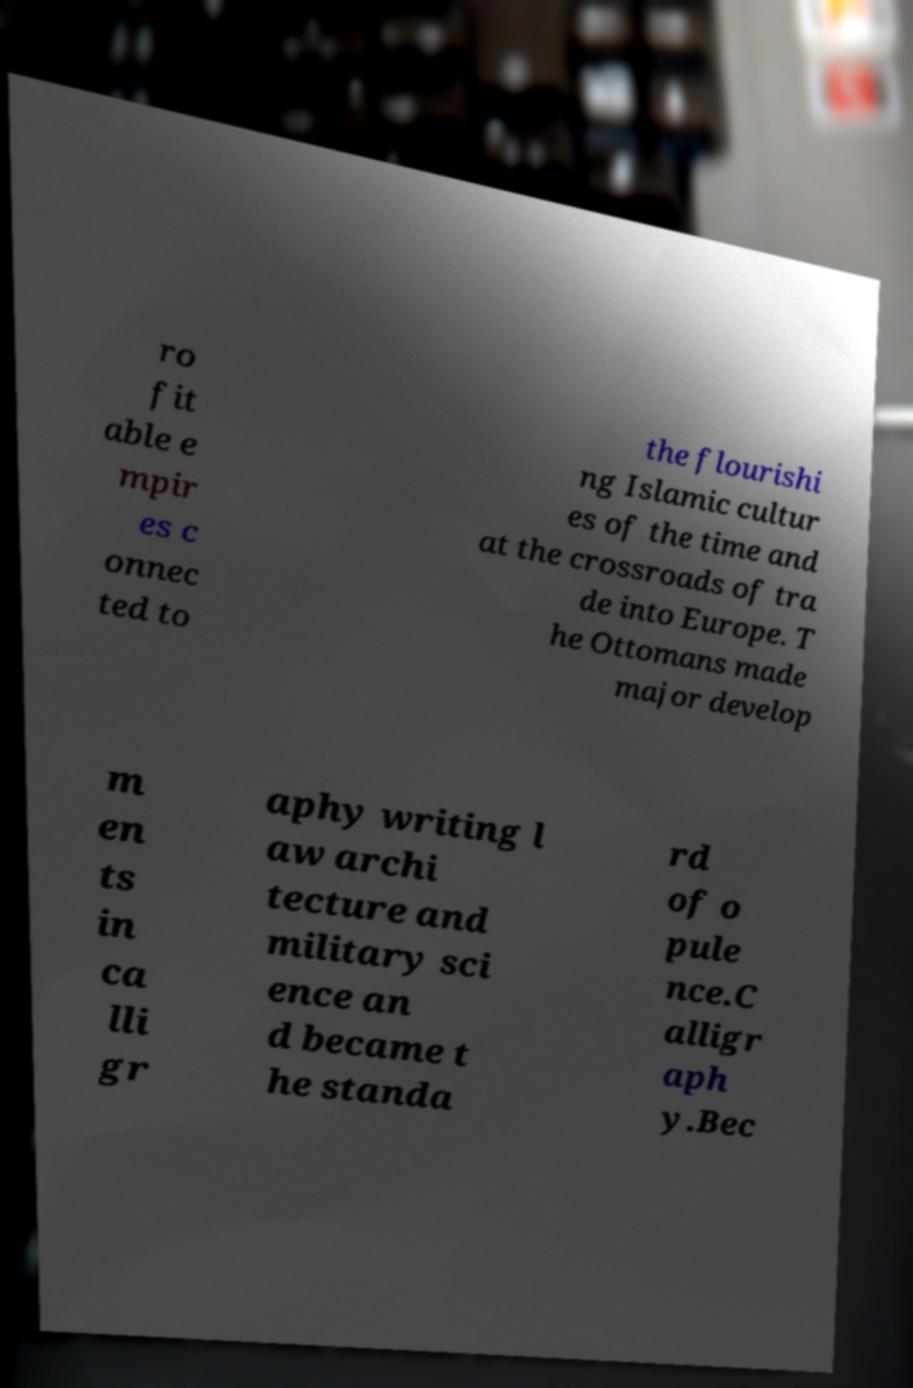Can you read and provide the text displayed in the image?This photo seems to have some interesting text. Can you extract and type it out for me? ro fit able e mpir es c onnec ted to the flourishi ng Islamic cultur es of the time and at the crossroads of tra de into Europe. T he Ottomans made major develop m en ts in ca lli gr aphy writing l aw archi tecture and military sci ence an d became t he standa rd of o pule nce.C alligr aph y.Bec 